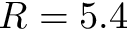<formula> <loc_0><loc_0><loc_500><loc_500>R = 5 . 4</formula> 